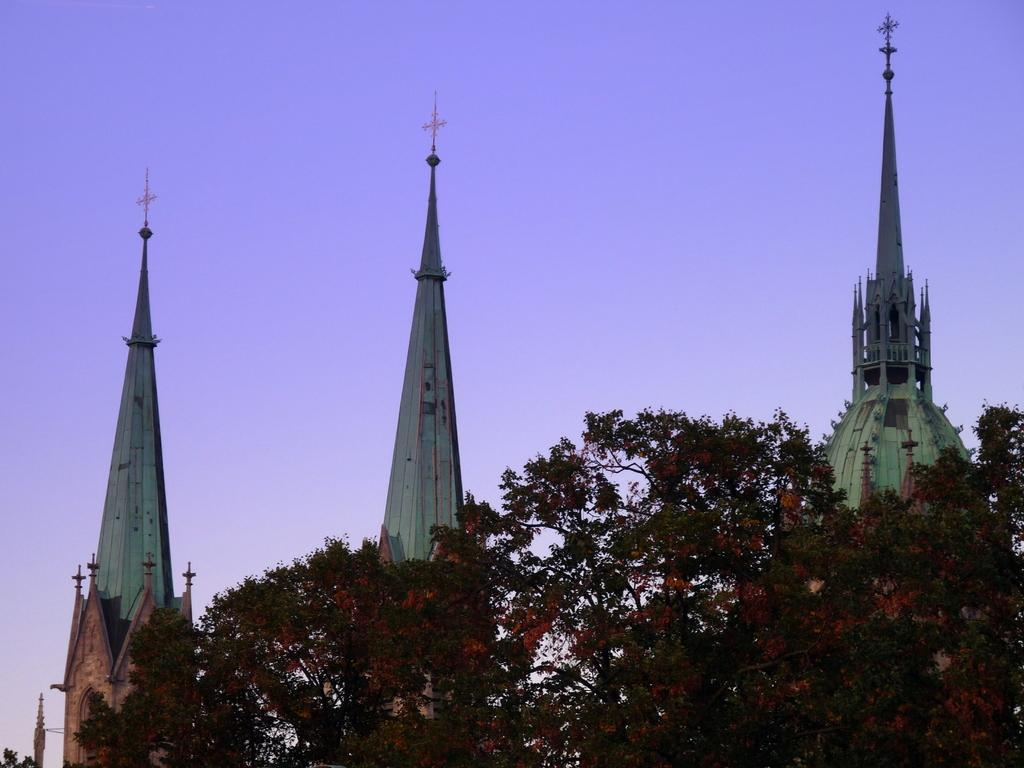What type of structures can be seen in the image? There are buildings in the image. What other natural elements are present in the image? There are trees in the image. What can be seen in the distance in the image? The sky is visible in the background of the image. What idea does the burst of light represent in the image? There is no burst of light present in the image; it only features buildings, trees, and the sky. 